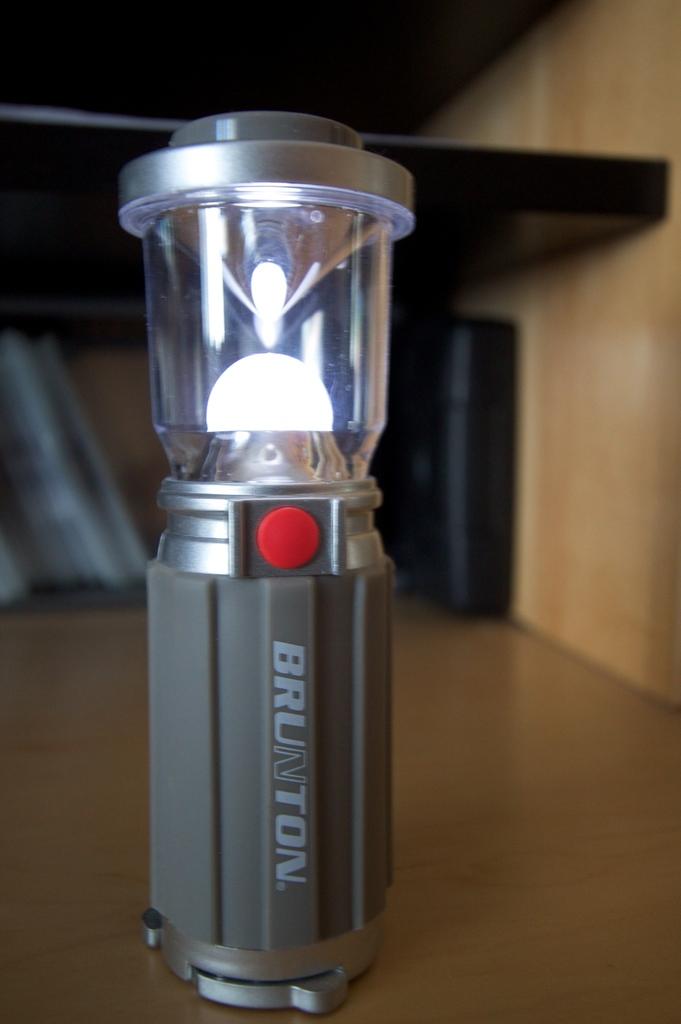What is the name of this lamp?
Ensure brevity in your answer.  Brunton. 